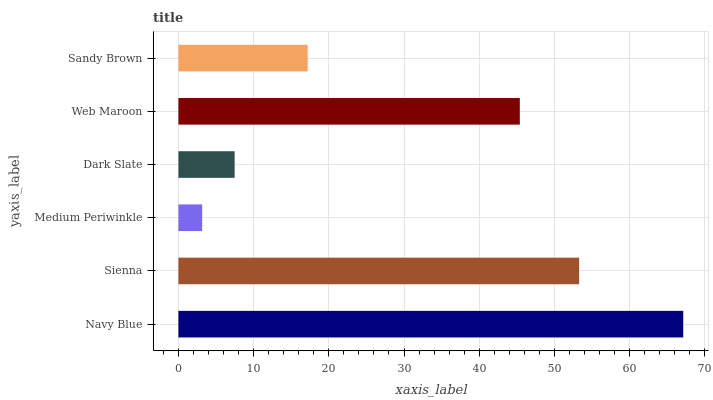Is Medium Periwinkle the minimum?
Answer yes or no. Yes. Is Navy Blue the maximum?
Answer yes or no. Yes. Is Sienna the minimum?
Answer yes or no. No. Is Sienna the maximum?
Answer yes or no. No. Is Navy Blue greater than Sienna?
Answer yes or no. Yes. Is Sienna less than Navy Blue?
Answer yes or no. Yes. Is Sienna greater than Navy Blue?
Answer yes or no. No. Is Navy Blue less than Sienna?
Answer yes or no. No. Is Web Maroon the high median?
Answer yes or no. Yes. Is Sandy Brown the low median?
Answer yes or no. Yes. Is Sandy Brown the high median?
Answer yes or no. No. Is Sienna the low median?
Answer yes or no. No. 